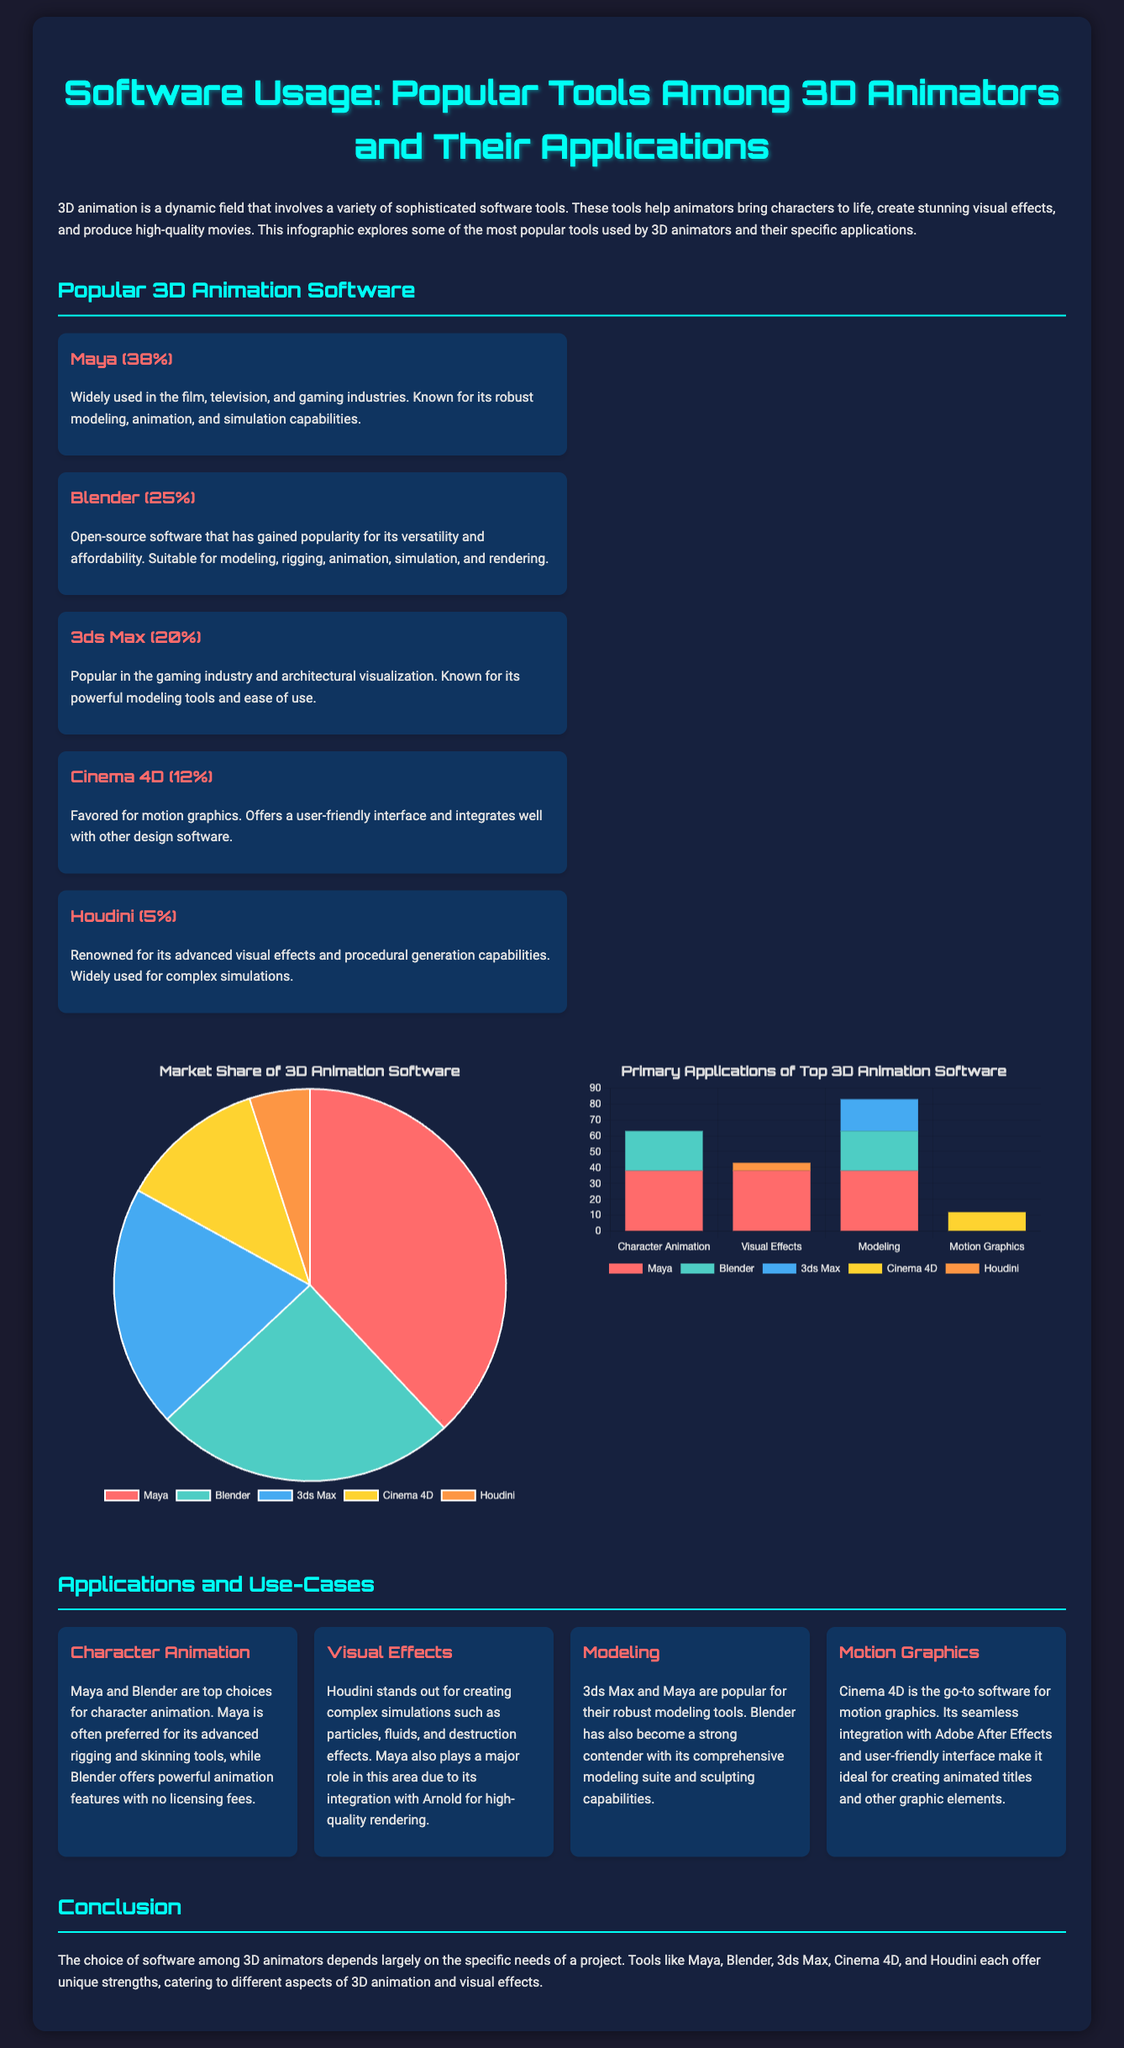What percentage of animators use Maya? The document states that Maya is used by 38% of animators.
Answer: 38% Which software is favored for motion graphics? The infographic indicates that Cinema 4D is the go-to software for motion graphics.
Answer: Cinema 4D What software is known for complex visual effects? The document mentions Houdini as renowned for its advanced visual effects.
Answer: Houdini How many software applications are listed in total? The document lists five software applications used by 3D animators.
Answer: Five According to the market share chart, what is the percentage for Blender? The market share chart shows that Blender accounts for 25% of the software usage.
Answer: 25% Which software has no application listed for Motion Graphics? The application bar chart indicates that 3ds Max has no listed application for Motion Graphics.
Answer: 3ds Max What is the primary application for Maya based on the document? The document mentions that character animation is a primary application for Maya.
Answer: Character Animation Which software has the lowest market share? The infographic notes that Houdini has the lowest market share at 5%.
Answer: Houdini What is the main advantage of Blender mentioned in the document? The document highlights Blender's versatility and affordability as its main advantages.
Answer: Versatility and affordability 